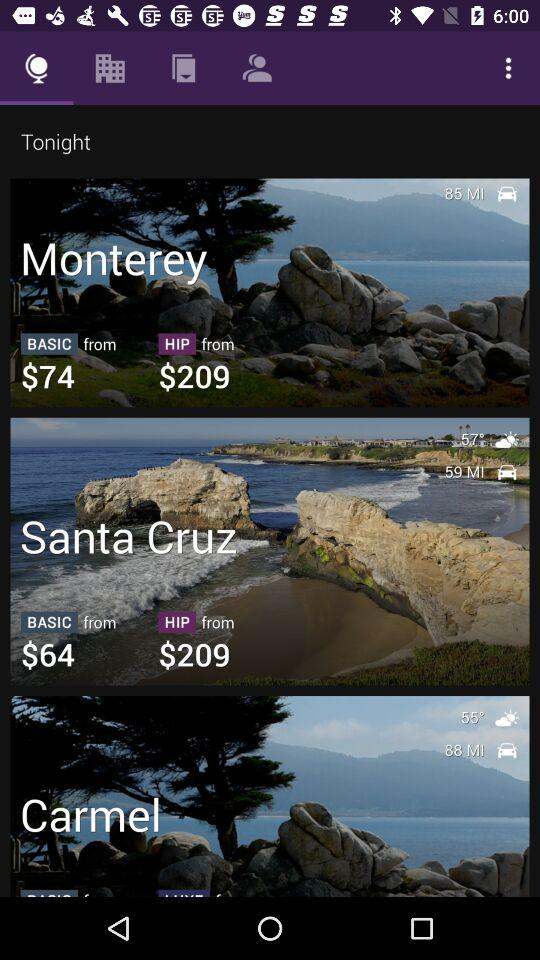What is the temperature in Santa Cruz? The temperature in Santa Cruz is 57°. 